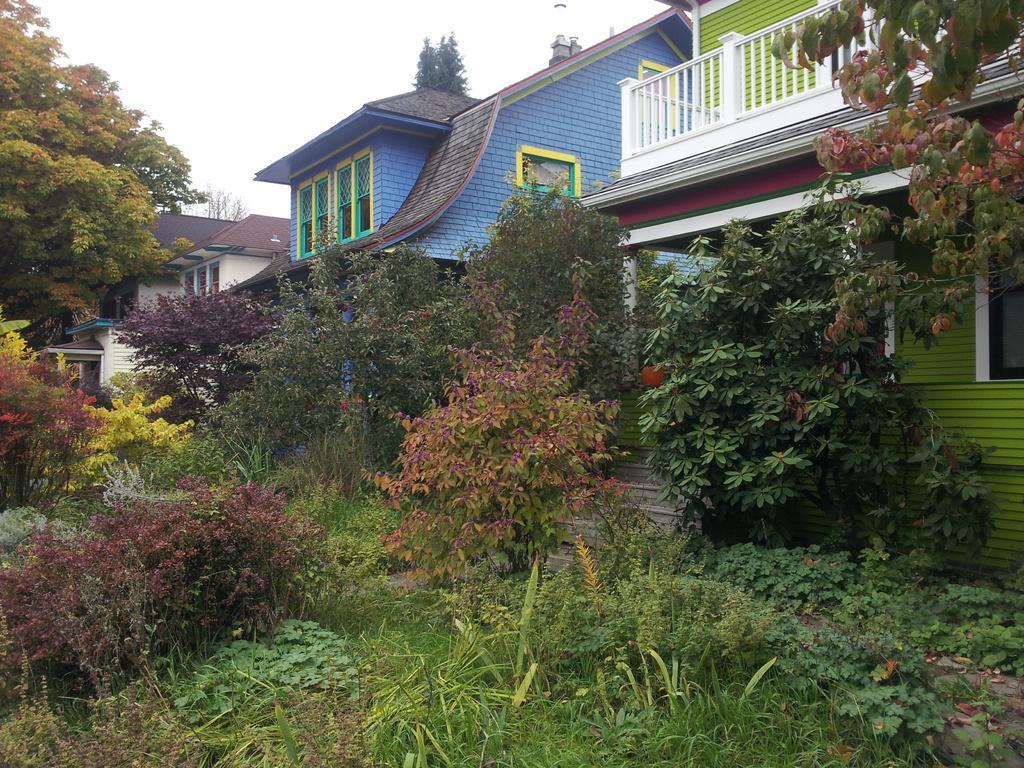Describe this image in one or two sentences. There are trees and houses, this is sky. 